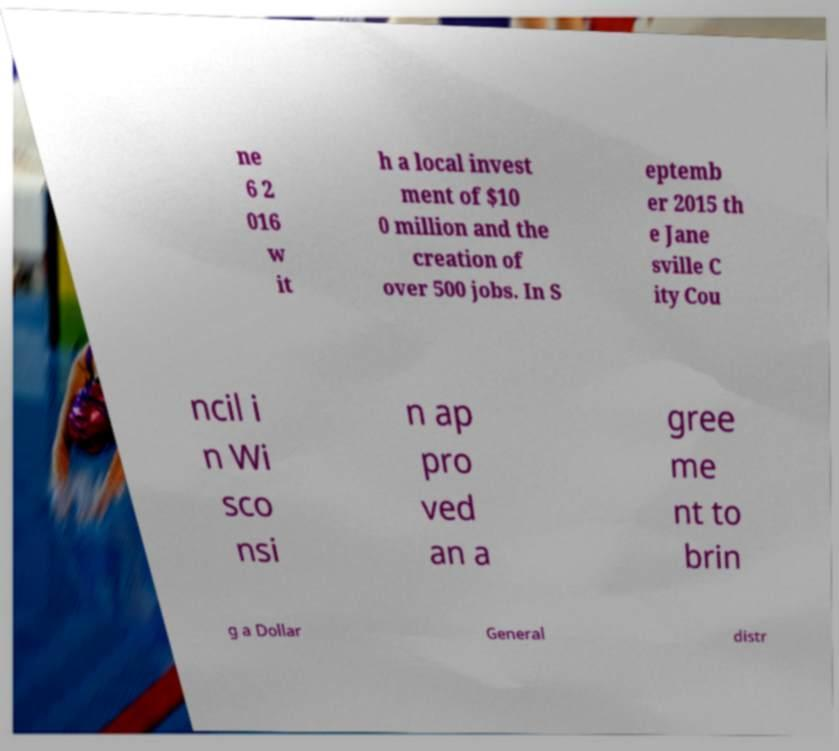What messages or text are displayed in this image? I need them in a readable, typed format. ne 6 2 016 w it h a local invest ment of $10 0 million and the creation of over 500 jobs. In S eptemb er 2015 th e Jane sville C ity Cou ncil i n Wi sco nsi n ap pro ved an a gree me nt to brin g a Dollar General distr 